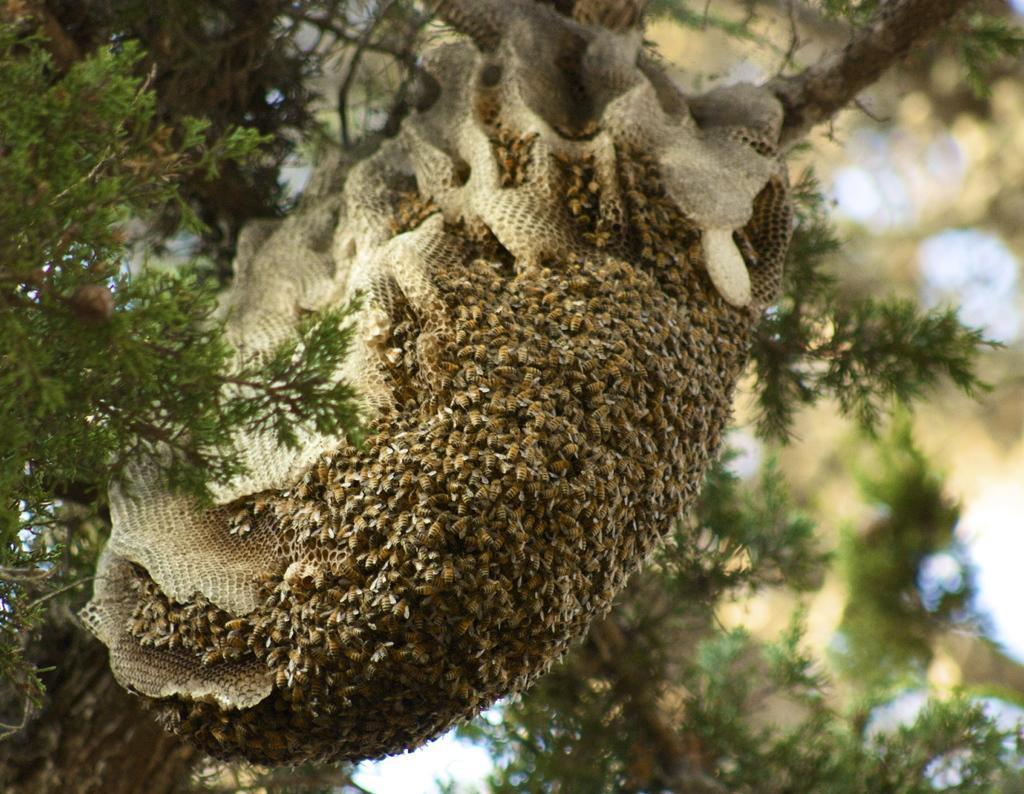In one or two sentences, can you explain what this image depicts? There is a honey bee hive on a tree. There are many honey bees. 